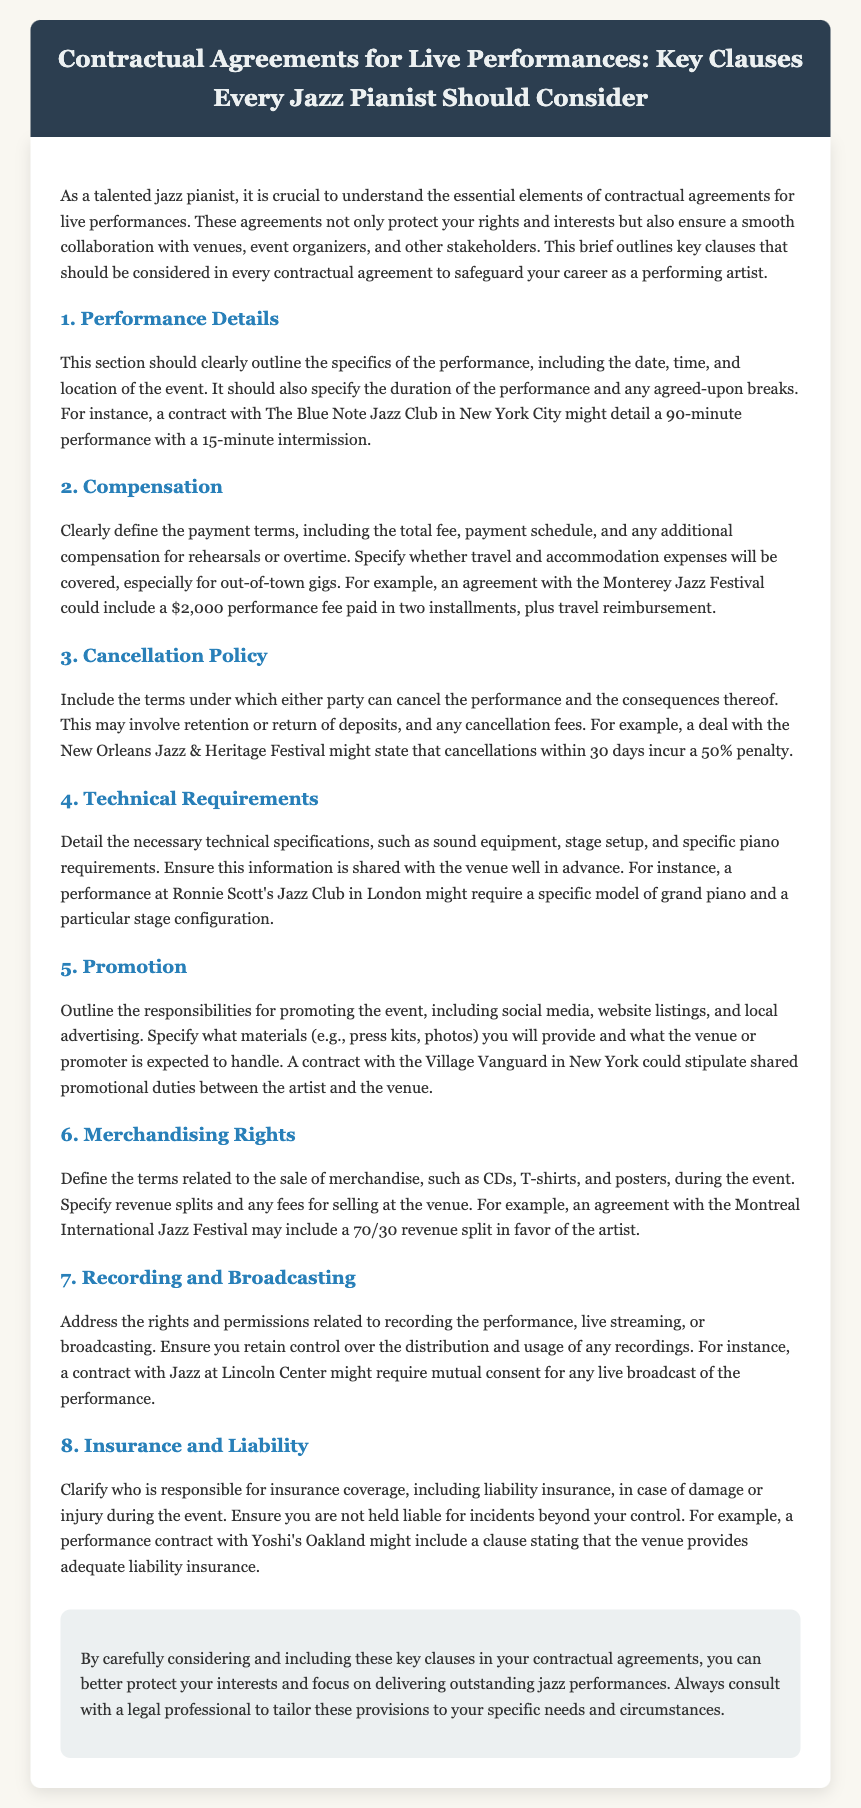What is outlined in the Performance Details clause? The Performance Details clause outlines the specifics of the performance, including date, time, location, duration, and breaks.
Answer: specifics of the performance What is the compensation fee example mentioned? The document provides an example of a performance fee, which is $2,000 paid in two installments.
Answer: $2,000 What is the cancellation fee penalty within 30 days? According to the document, cancellations within 30 days incur a 50% penalty.
Answer: 50% What technical specifications are required in the Technical Requirements clause? It mentions the necessary technical specifications such as sound equipment, stage setup, and specific piano requirements.
Answer: sound equipment, stage setup, specific piano requirements What does the Merchandising Rights clause define? The Merchandising Rights clause defines the terms related to the sale of merchandise during the event, specifying revenue splits.
Answer: sale of merchandise How does the document emphasize the importance of consulting a legal professional? The conclusion highlights the necessity of consulting with a legal professional to tailor provisions.
Answer: tailor provisions What is the purpose of including a Cancellation Policy? The Cancellation Policy outlines the terms under which either party can cancel the performance and the consequences.
Answer: terms for cancellation What is a specified requirement concerning recording and broadcasting? The document states that there should be mutual consent for any live broadcast of the performance.
Answer: mutual consent 